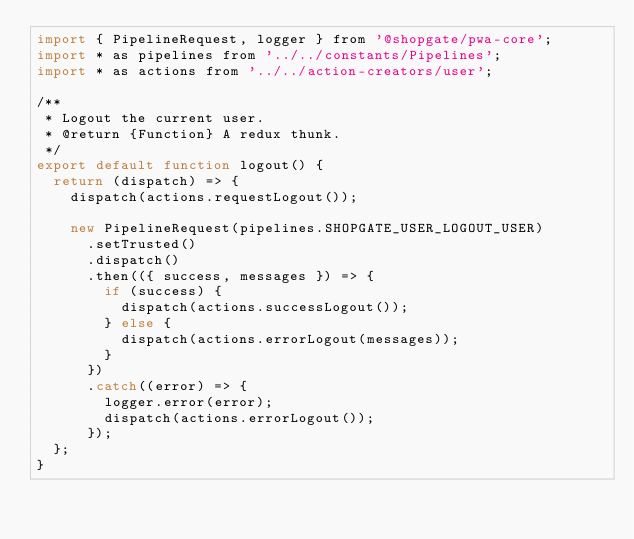Convert code to text. <code><loc_0><loc_0><loc_500><loc_500><_JavaScript_>import { PipelineRequest, logger } from '@shopgate/pwa-core';
import * as pipelines from '../../constants/Pipelines';
import * as actions from '../../action-creators/user';

/**
 * Logout the current user.
 * @return {Function} A redux thunk.
 */
export default function logout() {
  return (dispatch) => {
    dispatch(actions.requestLogout());

    new PipelineRequest(pipelines.SHOPGATE_USER_LOGOUT_USER)
      .setTrusted()
      .dispatch()
      .then(({ success, messages }) => {
        if (success) {
          dispatch(actions.successLogout());
        } else {
          dispatch(actions.errorLogout(messages));
        }
      })
      .catch((error) => {
        logger.error(error);
        dispatch(actions.errorLogout());
      });
  };
}
</code> 